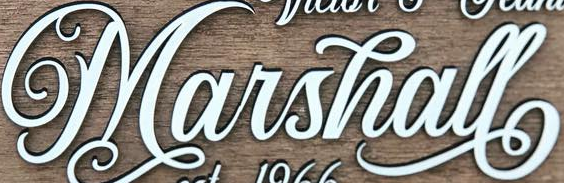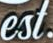What words are shown in these images in order, separated by a semicolon? Marshall; est 